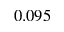Convert formula to latex. <formula><loc_0><loc_0><loc_500><loc_500>0 . 0 9 5</formula> 